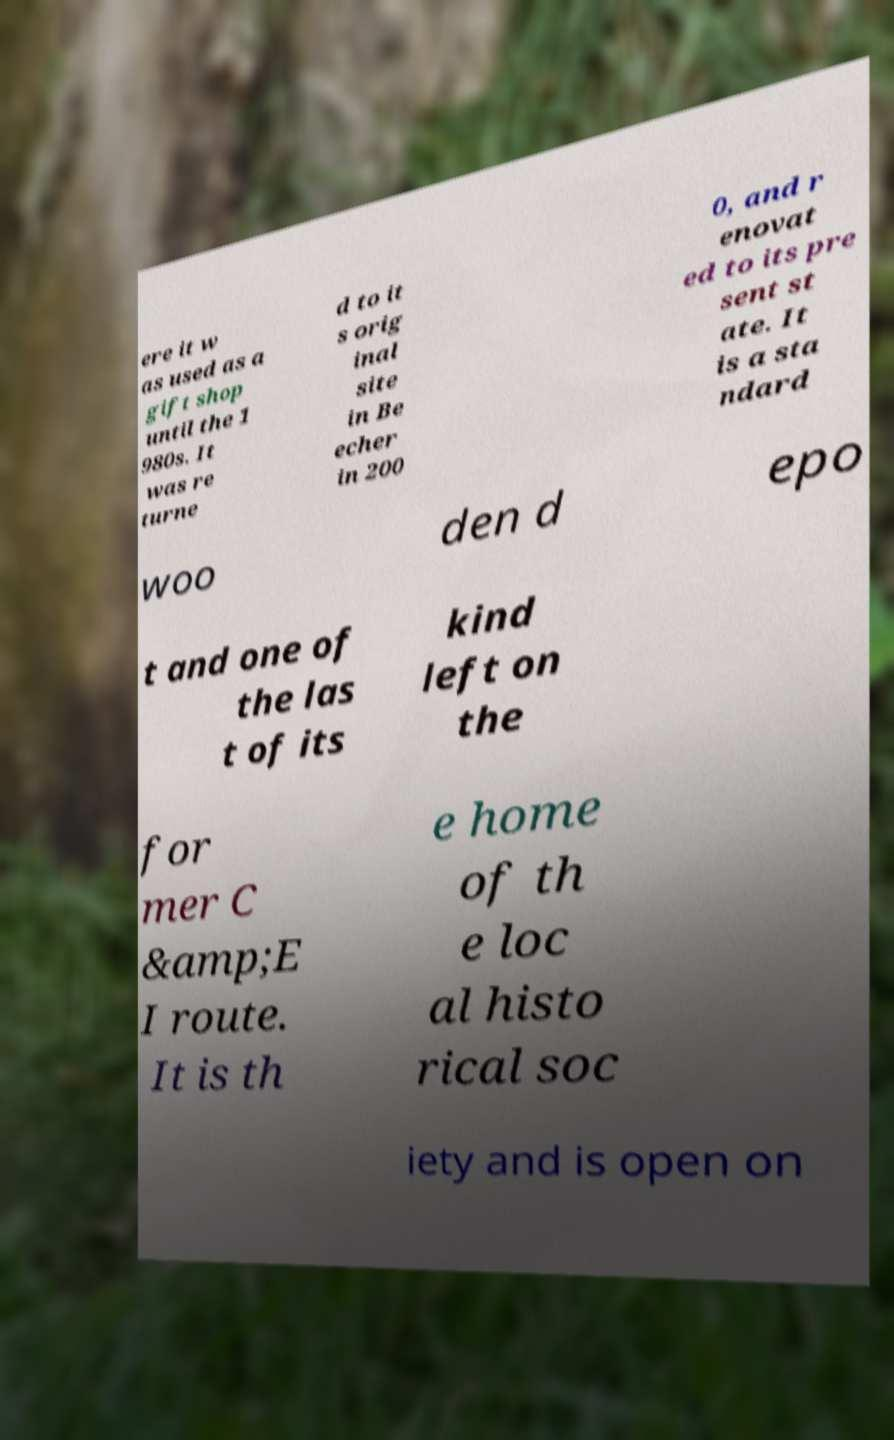There's text embedded in this image that I need extracted. Can you transcribe it verbatim? ere it w as used as a gift shop until the 1 980s. It was re turne d to it s orig inal site in Be echer in 200 0, and r enovat ed to its pre sent st ate. It is a sta ndard woo den d epo t and one of the las t of its kind left on the for mer C &amp;E I route. It is th e home of th e loc al histo rical soc iety and is open on 